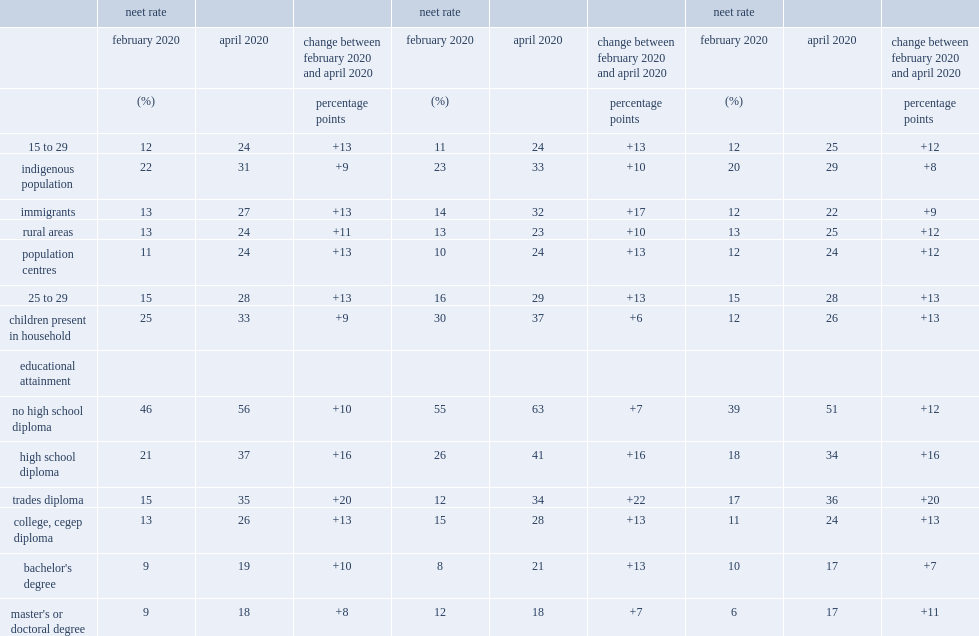From february 2020 to april 2020, how many percentage points did the neet rate for men aged 25 to 29 with children increase? 13.0. From february 2020 to april 2020, how many percentage points did the neet rate for women aged 25 to 29 with children increase? 6.0. 